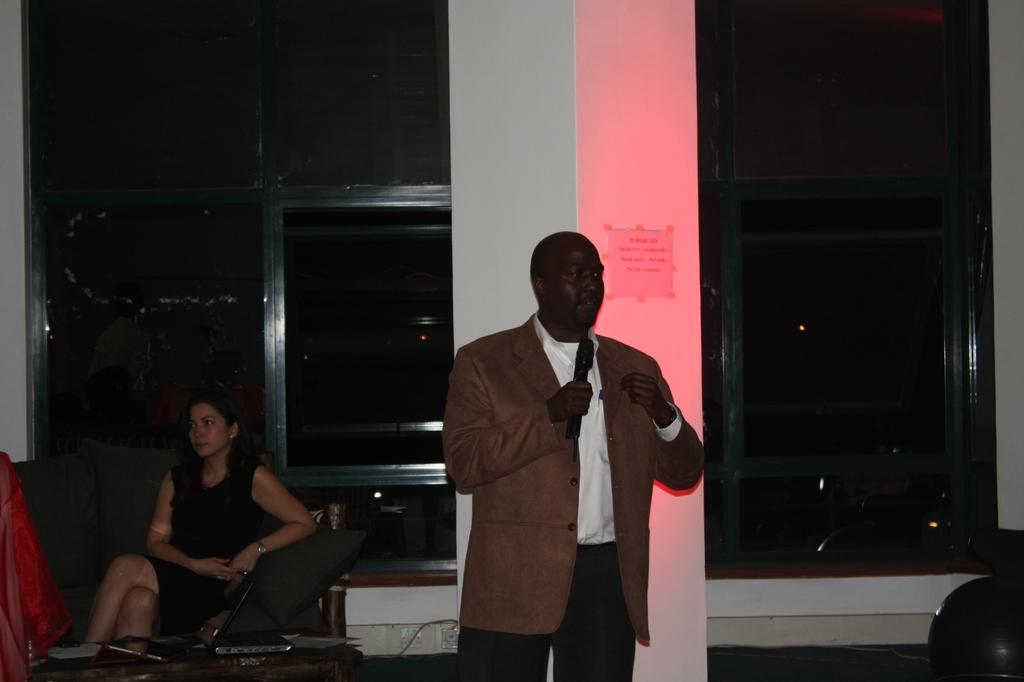What is the man in the image doing? The man is talking on a mic in the image. What is the woman in the image doing? The woman is sitting on a sofa in the image. What color is the light in the background? The light in the background is red. How would you describe the overall lighting in the image? The background is dark in the image. What type of payment is the man demanding from the woman in the image? There is no indication in the image that the man is demanding any payment from the woman. 